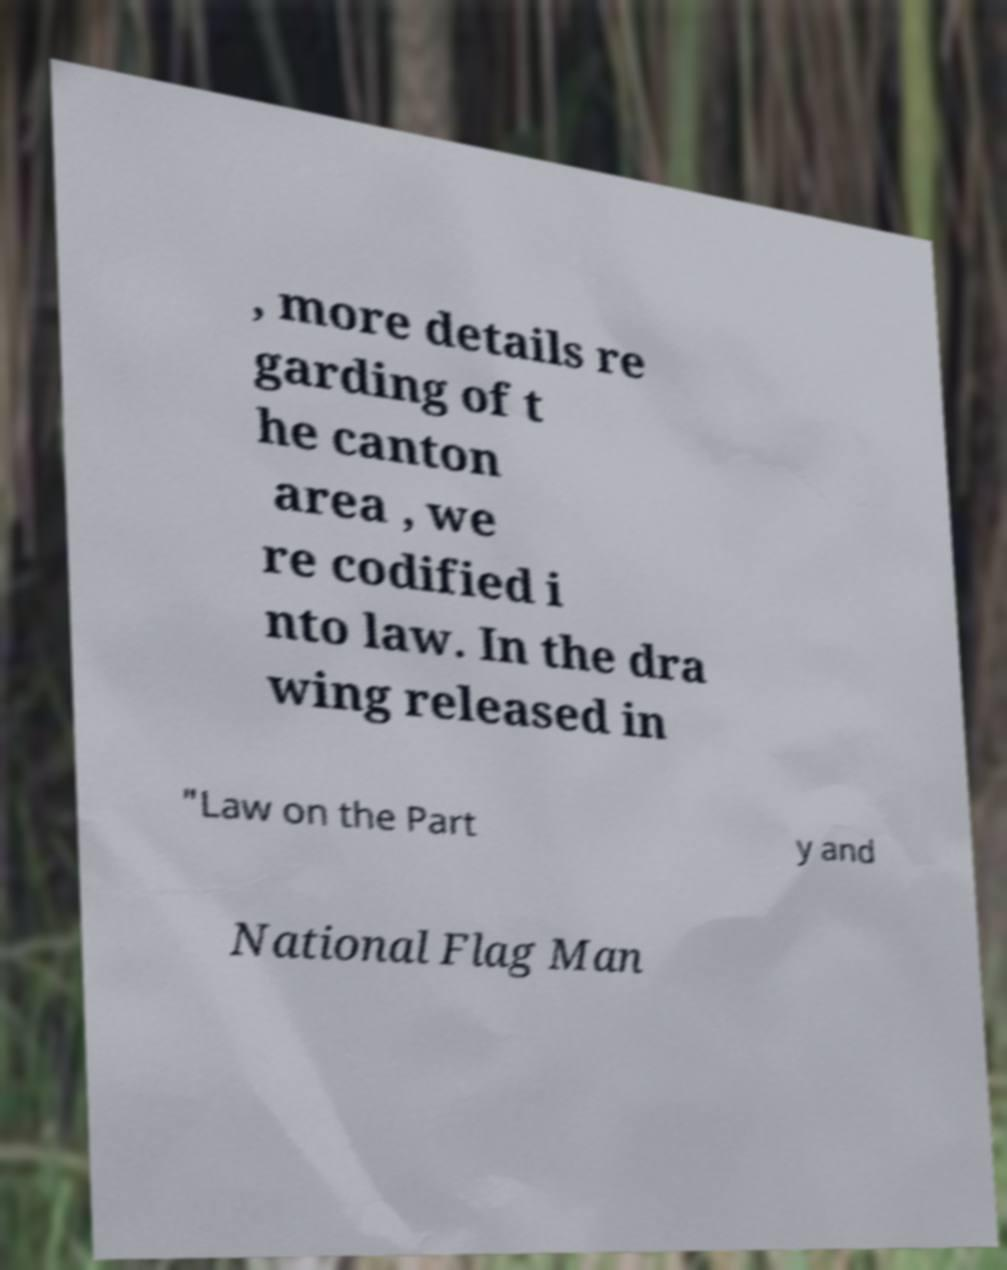Can you read and provide the text displayed in the image?This photo seems to have some interesting text. Can you extract and type it out for me? , more details re garding of t he canton area , we re codified i nto law. In the dra wing released in "Law on the Part y and National Flag Man 